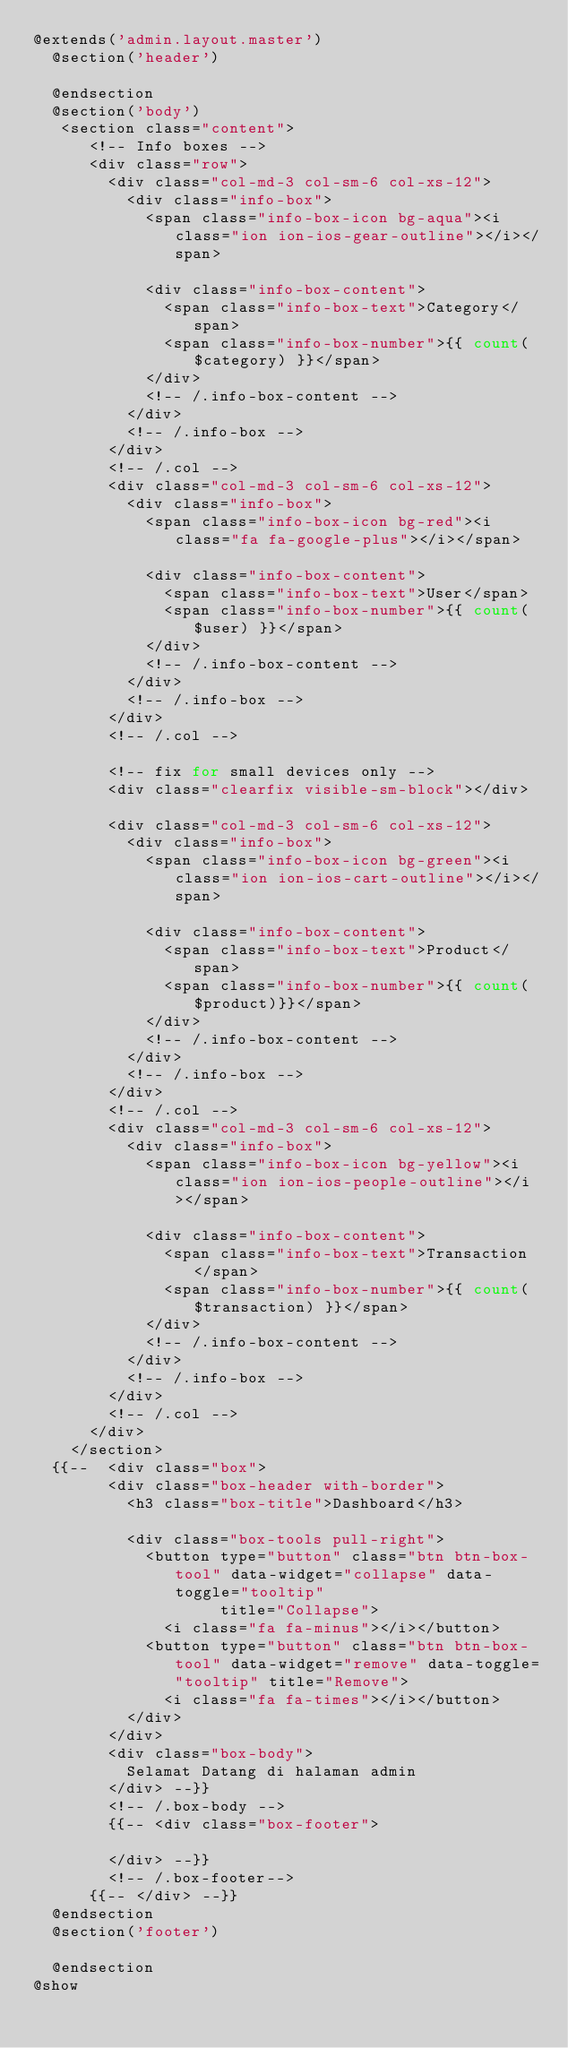<code> <loc_0><loc_0><loc_500><loc_500><_PHP_>@extends('admin.layout.master')
  @section('header')

  @endsection
  @section('body')
   <section class="content">
      <!-- Info boxes -->
      <div class="row">
        <div class="col-md-3 col-sm-6 col-xs-12">
          <div class="info-box">
            <span class="info-box-icon bg-aqua"><i class="ion ion-ios-gear-outline"></i></span>

            <div class="info-box-content">
              <span class="info-box-text">Category</span>
              <span class="info-box-number">{{ count($category) }}</span>
            </div>
            <!-- /.info-box-content -->
          </div>
          <!-- /.info-box -->
        </div>
        <!-- /.col -->
        <div class="col-md-3 col-sm-6 col-xs-12">
          <div class="info-box">
            <span class="info-box-icon bg-red"><i class="fa fa-google-plus"></i></span>

            <div class="info-box-content">
              <span class="info-box-text">User</span>
              <span class="info-box-number">{{ count($user) }}</span>
            </div>
            <!-- /.info-box-content -->
          </div>
          <!-- /.info-box -->
        </div>
        <!-- /.col -->

        <!-- fix for small devices only -->
        <div class="clearfix visible-sm-block"></div>

        <div class="col-md-3 col-sm-6 col-xs-12">
          <div class="info-box">
            <span class="info-box-icon bg-green"><i class="ion ion-ios-cart-outline"></i></span>

            <div class="info-box-content">
              <span class="info-box-text">Product</span>
              <span class="info-box-number">{{ count($product)}}</span>
            </div>
            <!-- /.info-box-content -->
          </div>
          <!-- /.info-box -->
        </div>
        <!-- /.col -->
        <div class="col-md-3 col-sm-6 col-xs-12">
          <div class="info-box">
            <span class="info-box-icon bg-yellow"><i class="ion ion-ios-people-outline"></i></span>

            <div class="info-box-content">
              <span class="info-box-text">Transaction</span>
              <span class="info-box-number">{{ count($transaction) }}</span>
            </div>
            <!-- /.info-box-content -->
          </div>
          <!-- /.info-box -->
        </div>
        <!-- /.col -->
      </div>
    </section>
  {{--  <div class="box">
        <div class="box-header with-border">
          <h3 class="box-title">Dashboard</h3>

          <div class="box-tools pull-right">
            <button type="button" class="btn btn-box-tool" data-widget="collapse" data-toggle="tooltip"
                    title="Collapse">
              <i class="fa fa-minus"></i></button>
            <button type="button" class="btn btn-box-tool" data-widget="remove" data-toggle="tooltip" title="Remove">
              <i class="fa fa-times"></i></button>
          </div>
        </div>
        <div class="box-body">
          Selamat Datang di halaman admin
        </div> --}}
        <!-- /.box-body -->
        {{-- <div class="box-footer">
          
        </div> --}}
        <!-- /.box-footer-->
      {{-- </div> --}}
  @endsection
  @section('footer')
    
  @endsection
@show</code> 